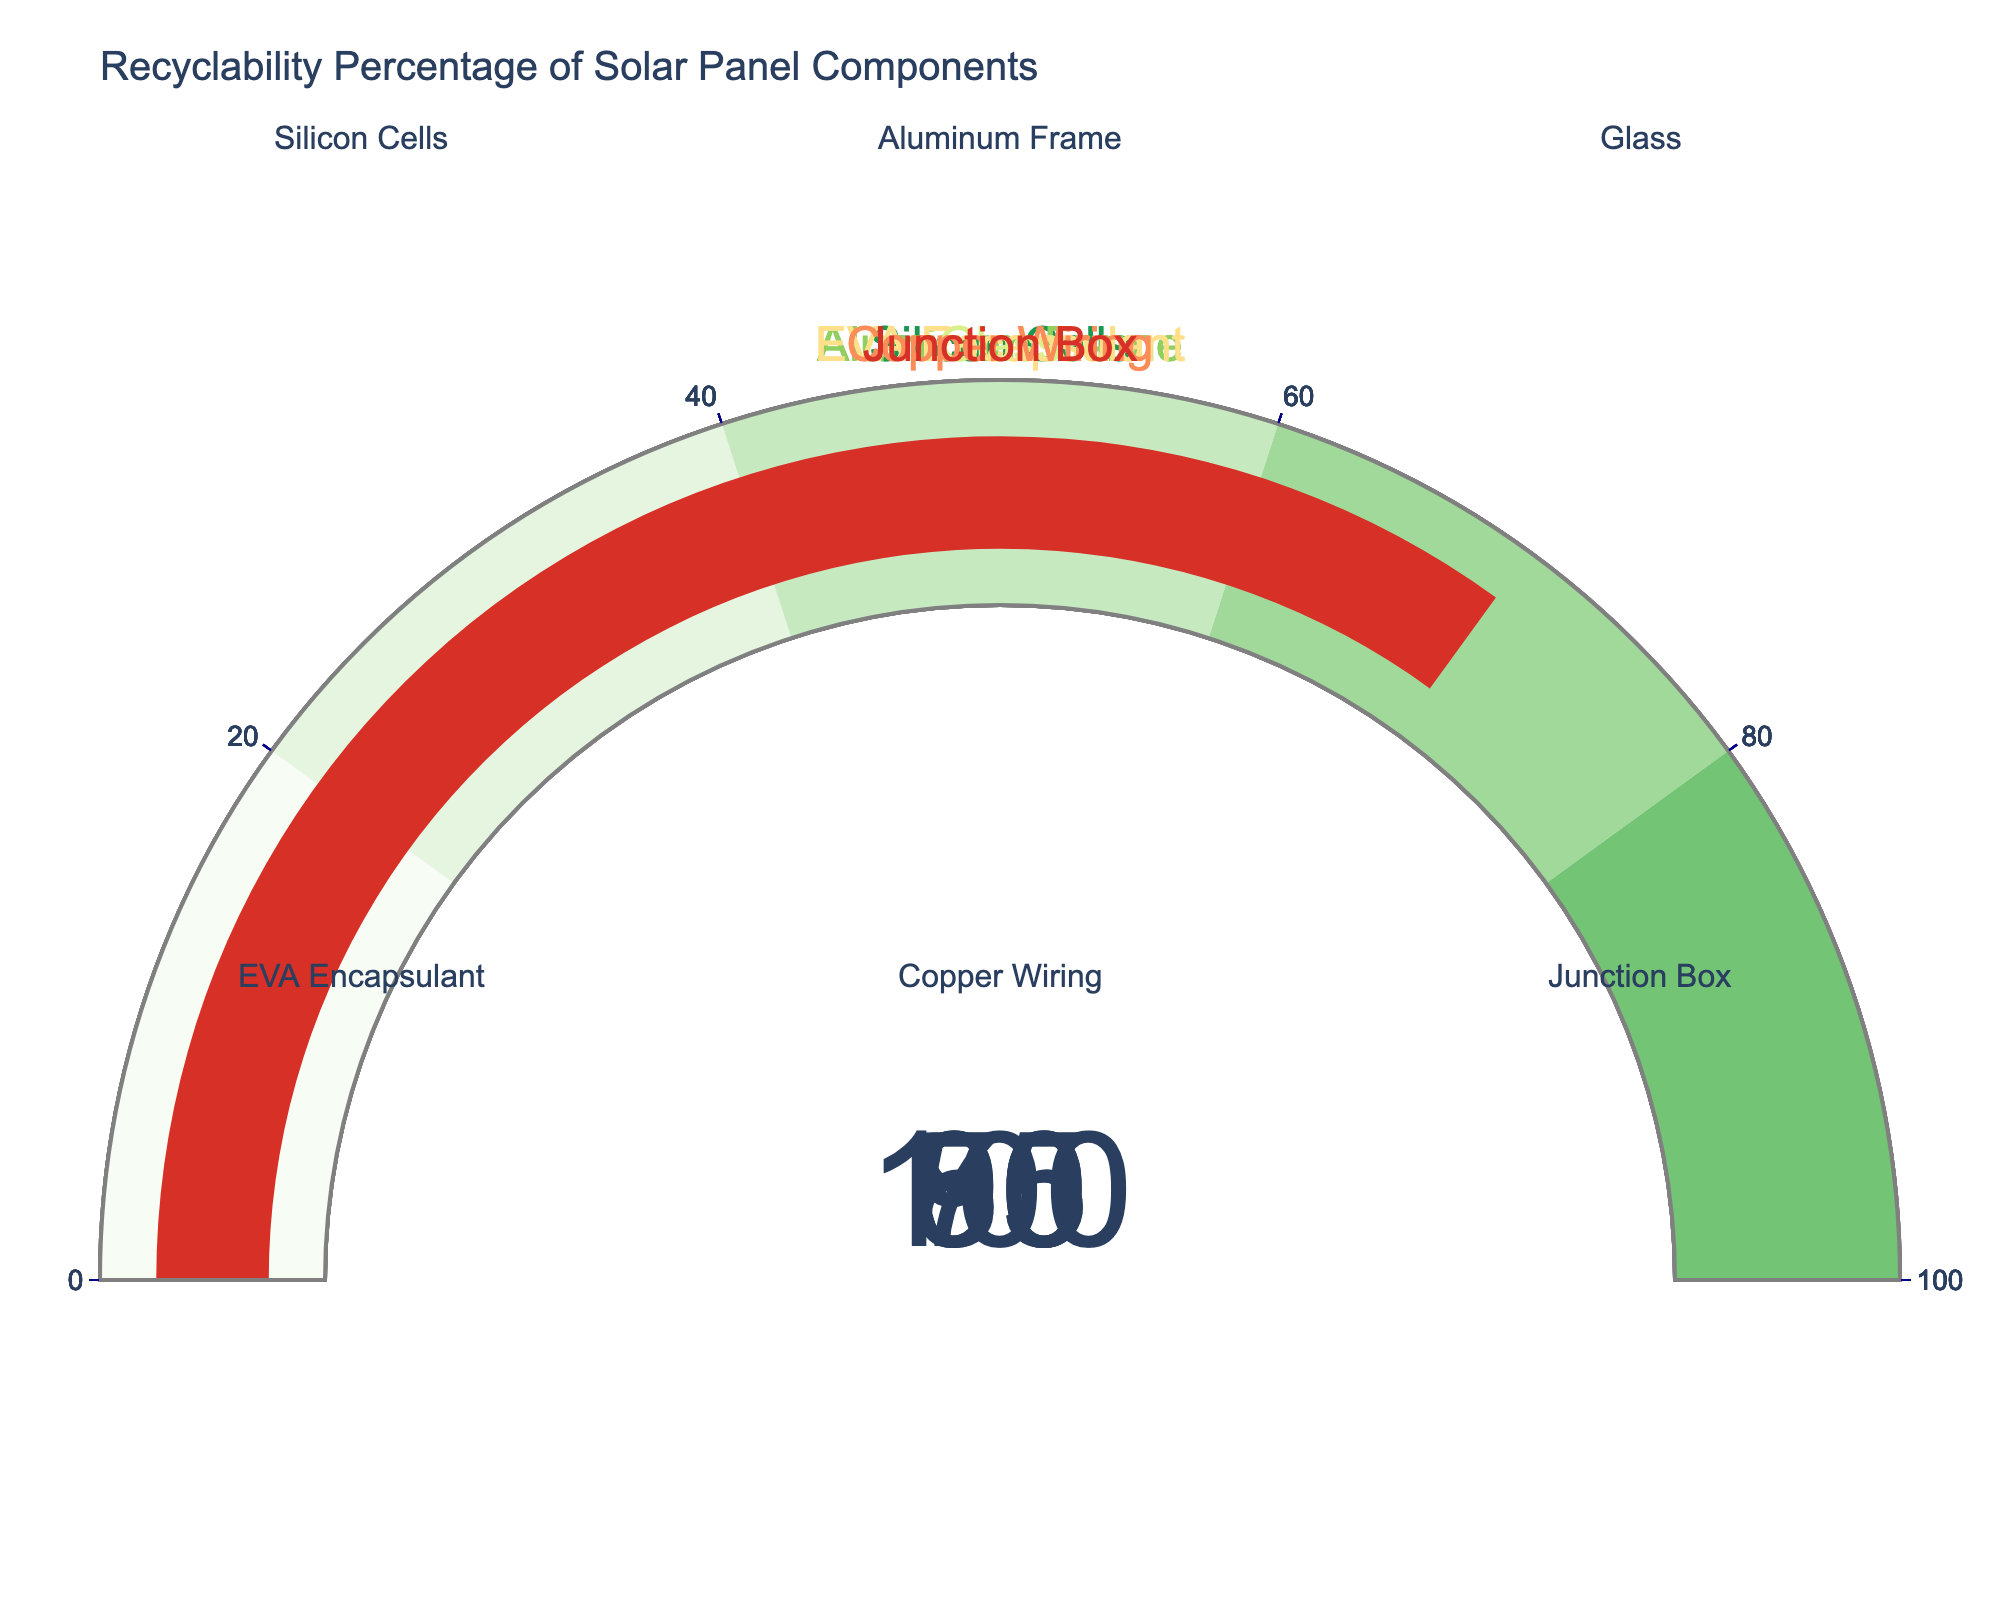Which component has the highest recyclability percentage? By scanning the figure for the gauge that displays the highest percentage, we see that the Aluminum Frame shows a recyclability percentage of 100%, which is the highest.
Answer: Aluminum Frame Which component has the lowest recyclability percentage? By identifying the gauge with the smallest value, we see the EVA Encapsulant has the lowest recyclability percentage at 50%.
Answer: EVA Encapsulant What is the median value of recyclability percentages? The recyclability percentages are 50, 70, 85, 90, 95, and 100. Ordering the values: 50, 70, 85, 90, 95, 100. The median is the average of the two middle values (85 and 90), which is (85 + 90) / 2 = 87.5
Answer: 87.5 Which components have a recyclability percentage greater than 80%? Components with recyclability percentages greater than 80 are Silicon Cells (95), Aluminum Frame (100), Glass (90), and Copper Wiring (85).
Answer: Silicon Cells, Aluminum Frame, Glass, Copper Wiring What is the average recyclability percentage of all components? Sum all the percentages: 95 + 100 + 90 + 50 + 85 + 70 = 490. Divide by the number of components (6): 490 / 6 = 81.67
Answer: 81.67 What is the range of recyclability percentages shown in the figure? The range is found by subtracting the smallest value (50) from the largest value (100): 100 - 50 = 50
Answer: 50 How many components have a recyclability percentage below 60%? Only one component (EVA Encapsulant) has a recyclability percentage below 60, which is at 50%.
Answer: 1 Which components have lower recyclability percentages than the median value? The median value is 87.5. Components with recyclability percentages lower than 87.5 are EVA Encapsulant (50), Junction Box (70), Copper Wiring (85), and Glass (90). Only the first three are below 87.5.
Answer: EVA Encapsulant, Junction Box, Copper Wiring 